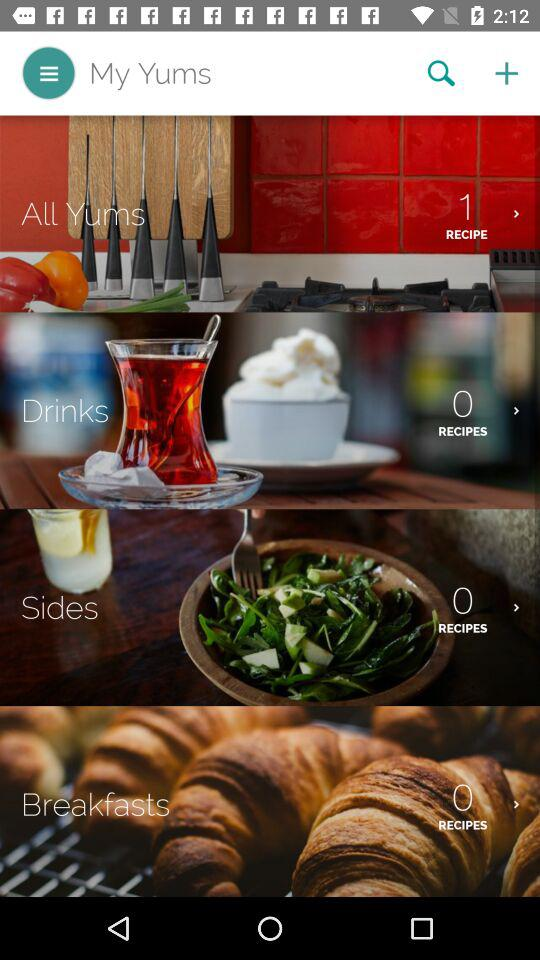How many recipes are in "All Yums"? There is 1 recipe in "All Yums". 